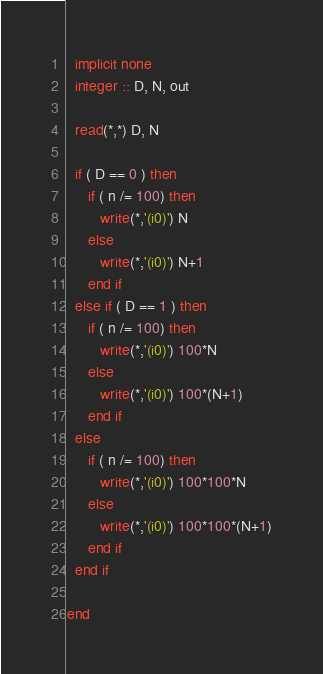<code> <loc_0><loc_0><loc_500><loc_500><_FORTRAN_>  implicit none
  integer :: D, N, out

  read(*,*) D, N

  if ( D == 0 ) then
     if ( n /= 100) then
        write(*,'(i0)') N
     else 
        write(*,'(i0)') N+1
     end if
  else if ( D == 1 ) then
     if ( n /= 100) then
        write(*,'(i0)') 100*N
     else 
        write(*,'(i0)') 100*(N+1)
     end if
  else
     if ( n /= 100) then
        write(*,'(i0)') 100*100*N
     else 
        write(*,'(i0)') 100*100*(N+1)
     end if
  end if
     
end
</code> 